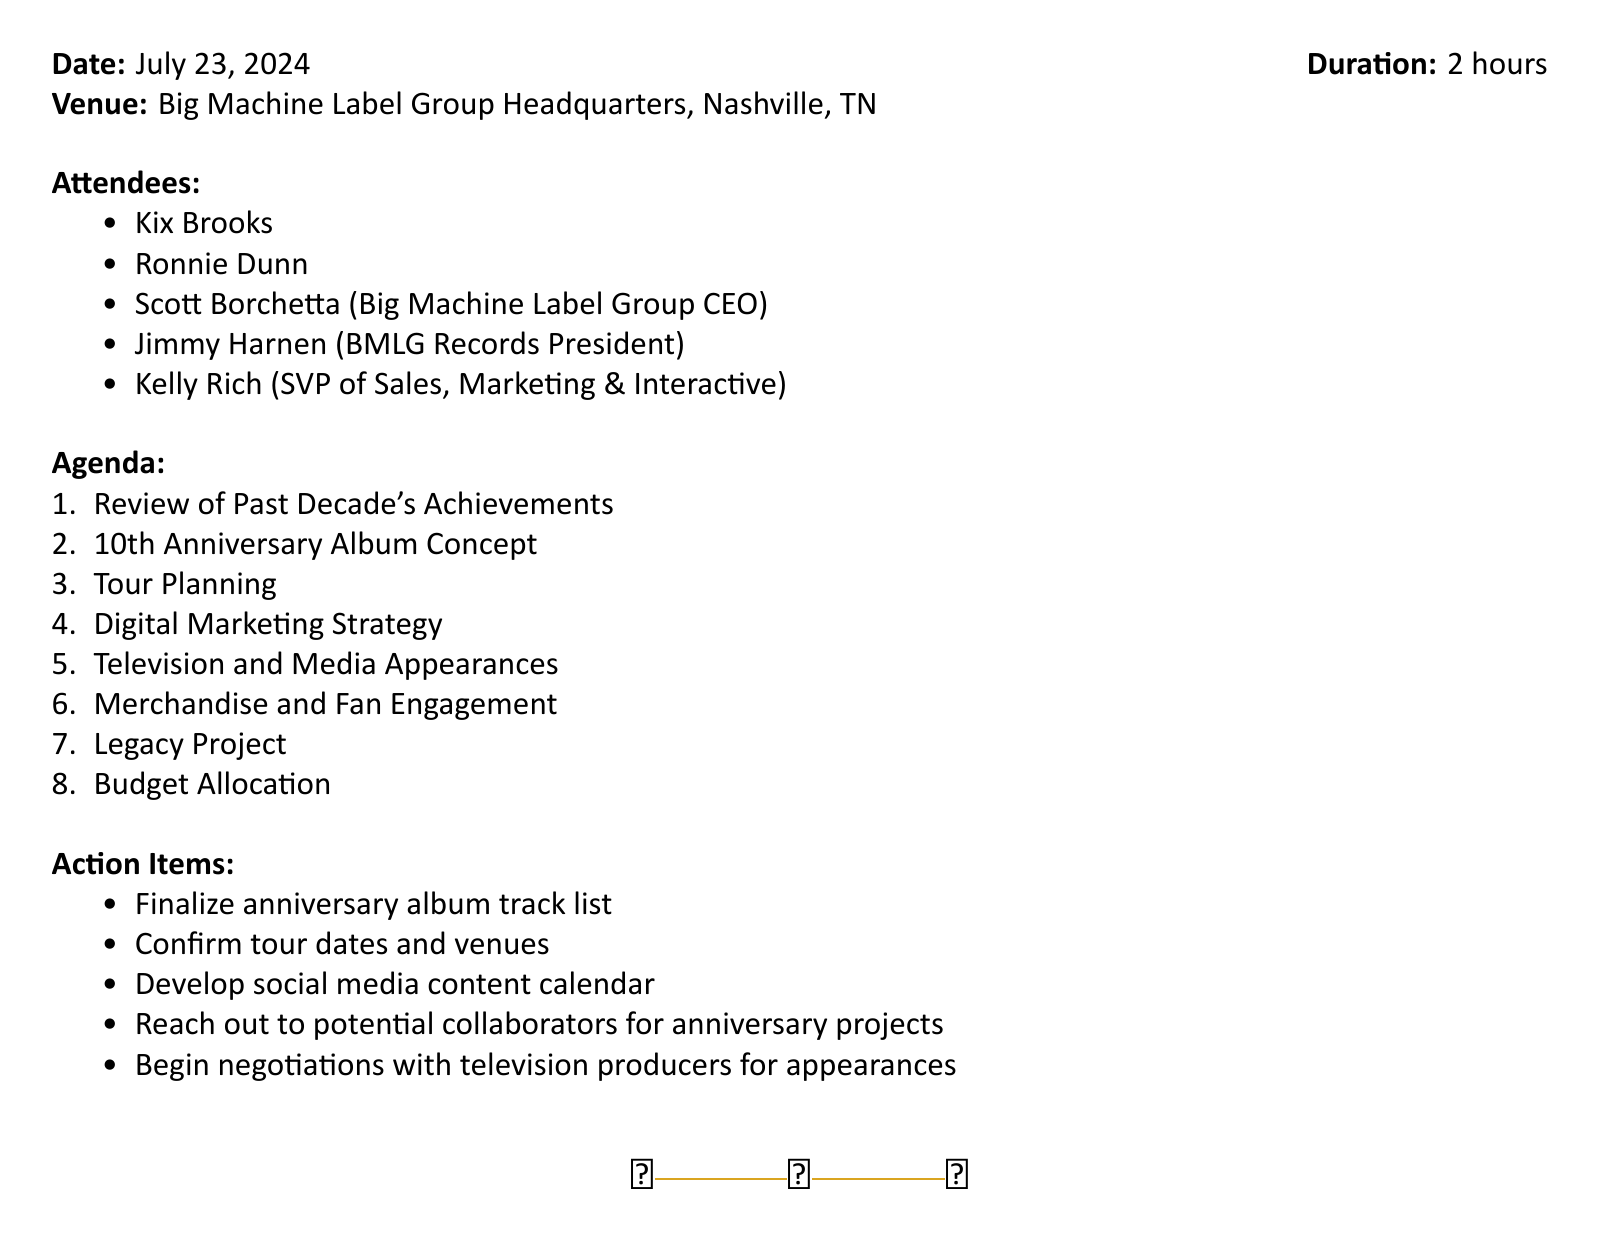What is the title of the meeting? The title of the meeting is stated at the beginning of the document.
Answer: Brooks & Dunn 10th Anniversary Marketing Strategy Meeting Who will be attending the meeting? The attendees list provides names of those who will be present at the meeting.
Answer: Kix Brooks, Ronnie Dunn, Scott Borchetta, Jimmy Harnen, Kelly Rich What is the duration of the meeting? The document clearly states the duration of the meeting in hours.
Answer: 2 hours What is one item discussed under Digital Marketing Strategy? The agenda item gives specific strategies to be outlined in the meeting.
Answer: Social media campaigns How many No. 1 hits does Brooks & Dunn have? The document mentions the total number of No. 1 hits in the context of achievements.
Answer: 20 Which major festivals are mentioned for the tour planning? The tour planning section includes specific festivals that are discussed.
Answer: CMA Fest, Stagecoach What will be proposed as a Legacy Project? The Legacy Project section indicates a specific type of project related to the duo's career.
Answer: Documentary or book What is one action item identified for the marketing strategy? The action items section lists specific tasks to be completed following the meeting.
Answer: Finalize anniversary album track list 